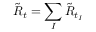Convert formula to latex. <formula><loc_0><loc_0><loc_500><loc_500>\tilde { R } _ { t } = \sum _ { I } \tilde { R } _ { t _ { I } }</formula> 